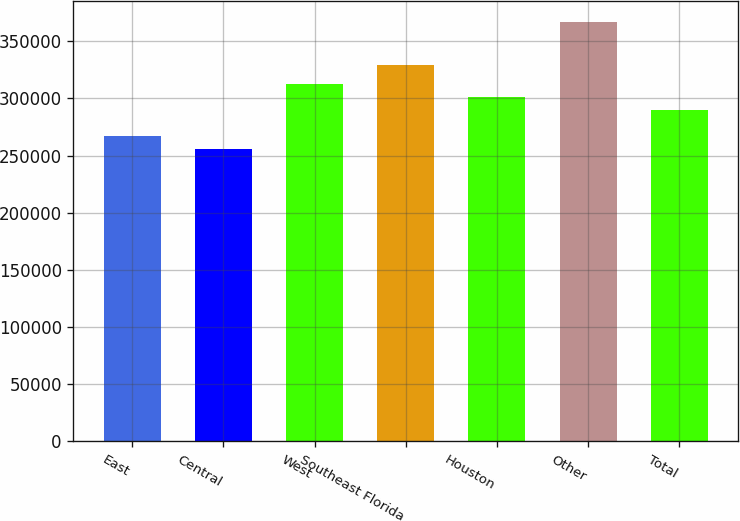Convert chart to OTSL. <chart><loc_0><loc_0><loc_500><loc_500><bar_chart><fcel>East<fcel>Central<fcel>West<fcel>Southeast Florida<fcel>Houston<fcel>Other<fcel>Total<nl><fcel>267100<fcel>256000<fcel>312200<fcel>329000<fcel>301100<fcel>367000<fcel>290000<nl></chart> 